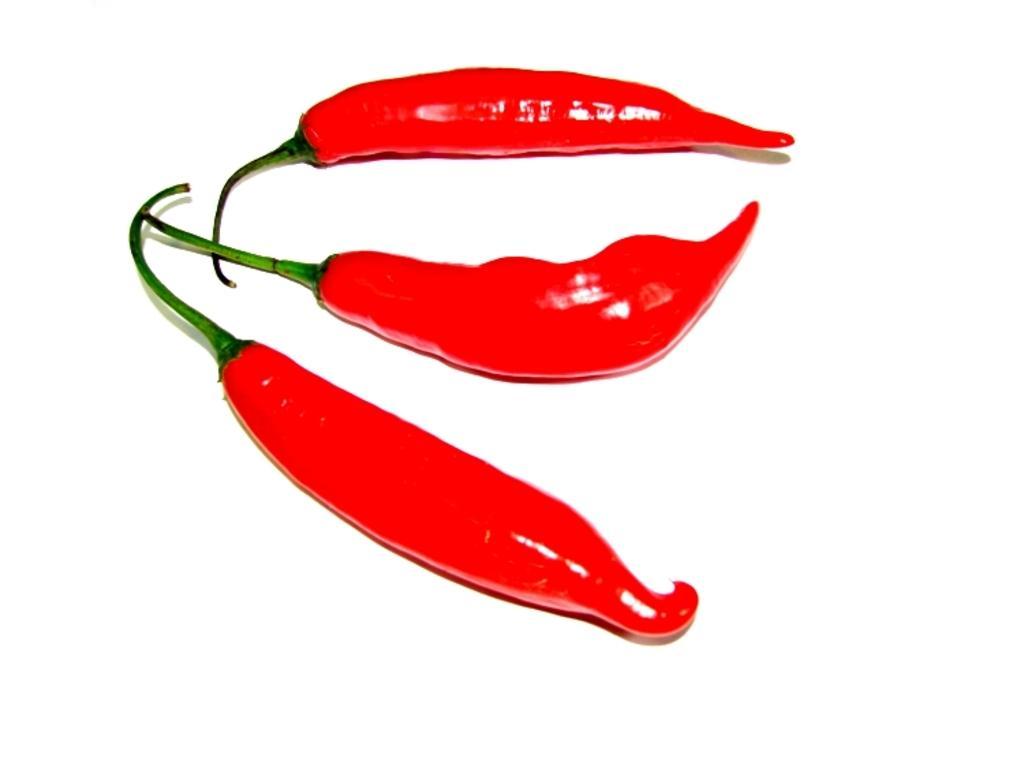Please provide a concise description of this image. In this image we can see few red chilies. There is a white background in the image. 